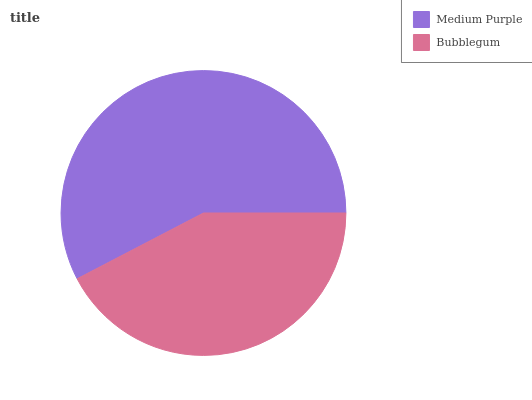Is Bubblegum the minimum?
Answer yes or no. Yes. Is Medium Purple the maximum?
Answer yes or no. Yes. Is Bubblegum the maximum?
Answer yes or no. No. Is Medium Purple greater than Bubblegum?
Answer yes or no. Yes. Is Bubblegum less than Medium Purple?
Answer yes or no. Yes. Is Bubblegum greater than Medium Purple?
Answer yes or no. No. Is Medium Purple less than Bubblegum?
Answer yes or no. No. Is Medium Purple the high median?
Answer yes or no. Yes. Is Bubblegum the low median?
Answer yes or no. Yes. Is Bubblegum the high median?
Answer yes or no. No. Is Medium Purple the low median?
Answer yes or no. No. 